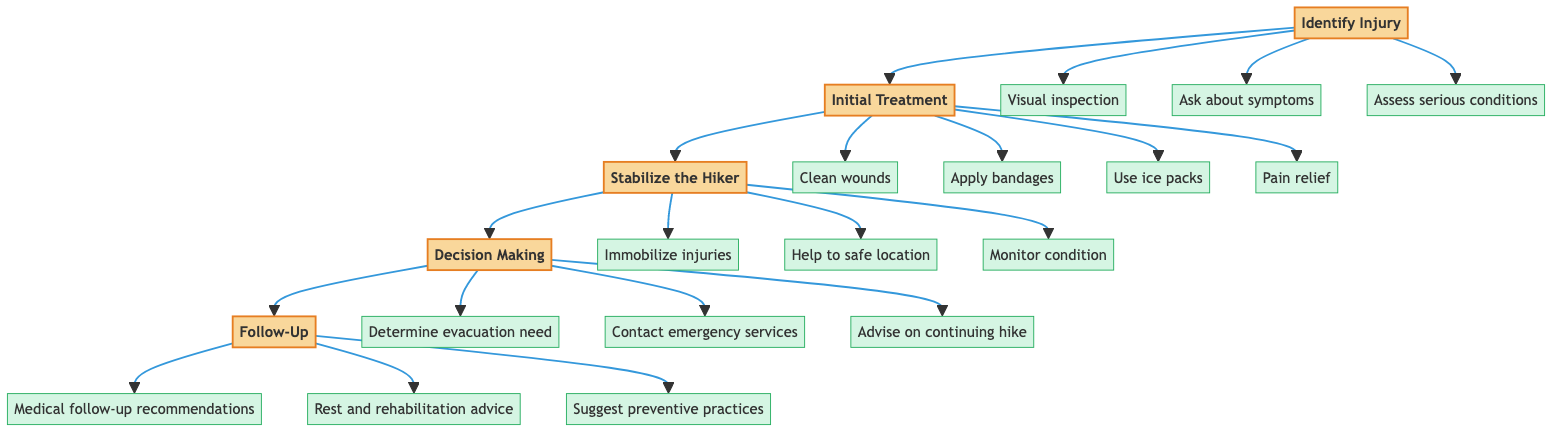What are the first three actions in the "Identify Injury" step? The actions listed under "Identify Injury" are: "Visually inspect affected area," "Ask hiker about symptoms and pain levels," and "Assess for potential serious conditions (e.g., fractures, concussions)."
Answer: Visually inspect affected area, Ask hiker about symptoms and pain levels, Assess for potential serious conditions (e.g., fractures, concussions) How many steps are involved in this clinical pathway? The diagram shows five distinct steps: "Identify Injury," "Initial Treatment," "Stabilize the Hiker," "Decision Making," and "Follow-Up." Thus, the total number of steps is five.
Answer: 5 Which step comes after "Initial Treatment"? According to the flow direction of the diagram, it transitions from "Initial Treatment" to "Stabilize the Hiker," indicating that "Stabilize the Hiker" is the next step.
Answer: Stabilize the Hiker What actions are included in the "Decision Making" step? The actions listed under "Decision Making" are: "Determine need for evacuation based on injury severity," "Contact emergency services if injury is beyond basic first aid," and "Advisement on continuing or terminating the hike based on injury."
Answer: Determine need for evacuation based on injury severity, Contact emergency services if injury is beyond basic first aid, Advisement on continuing or terminating the hike based on injury What is the purpose of the "Follow-Up" step? The "Follow-Up" step provides recommendations for ongoing care, including medical follow-up, advice on rest and rehabilitation, and suggestions for sustainable practices to prevent future injuries.
Answer: Recommendations for medical follow-up, advice on rest and rehabilitation, and suggestions for sustainable practices to prevent future injuries What is one action that is part of stabilizing the hiker? One of the actions listed under "Stabilize the Hiker" is "Immobilize any suspected fractures or sprains using splints or supports."
Answer: Immobilize any suspected fractures or sprains using splints or supports What does the initial treatment step focus on? The "Initial Treatment" step focuses primarily on managing minor injuries through cleaning wounds, applying bandages, using ice packs for swelling, and administering pain relief if necessary.
Answer: Managing minor injuries through cleaning wounds, applying bandages, using ice packs for swelling, and administering pain relief if necessary In which step should emergency services be contacted? Emergency services should be contacted during the "Decision Making" step if the injury is beyond basic first aid, indicating a more severe injury requiring professional assistance.
Answer: Decision Making How many actions are listed under the "Stabilize the Hiker" step? There are three actions listed under the "Stabilize the Hiker" step: "Immobilize any suspected fractures or sprains using splints or supports," "Help the hiker to a safe location if they can't move independently," and "Monitor for shock or changes in condition." Thus, the number is three.
Answer: 3 